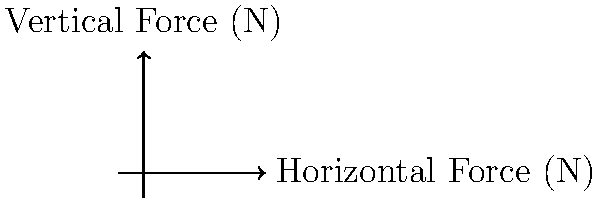The graph shows force vectors representing the ground reaction forces for three different horseshoe designs (A, B, and C) during a trot. Which design likely provides the best traction and stability for the horse? To determine which horseshoe design provides the best traction and stability, we need to analyze the force vectors:

1. Vector magnitude: A larger magnitude indicates a stronger overall force.
   A: $\sqrt{3^2 + 4^2} = 5$ N
   B: $\sqrt{4^2 + 2^2} \approx 4.47$ N
   C: $\sqrt{2^2 + 3^2} \approx 3.61$ N

2. Vertical component: A larger vertical component helps with shock absorption.
   A: 4 N
   B: 2 N
   C: 3 N

3. Horizontal component: A larger horizontal component provides better traction.
   A: 3 N
   B: 4 N
   C: 2 N

4. Angle with the ground: A more acute angle generally provides better stability.
   A: $\tan^{-1}(4/3) \approx 53.1°$
   B: $\tan^{-1}(2/4) \approx 26.6°$
   C: $\tan^{-1}(3/2) \approx 56.3°$

Design A has the largest magnitude and vertical component, providing good overall force and shock absorption. It also has a balanced horizontal component for traction.

Design B has the largest horizontal component, offering the best traction, but its vertical component is the smallest, potentially reducing shock absorption.

Design C has moderate values for all components but doesn't excel in any particular aspect.

Considering all factors, Design A likely provides the best combination of traction and stability due to its balanced force distribution and larger magnitude.
Answer: Design A 